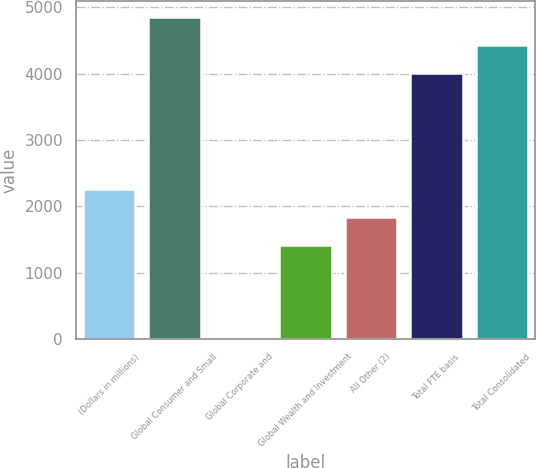Convert chart. <chart><loc_0><loc_0><loc_500><loc_500><bar_chart><fcel>(Dollars in millions)<fcel>Global Consumer and Small<fcel>Global Corporate and<fcel>Global Wealth and Investment<fcel>All Other (2)<fcel>Total FTE basis<fcel>Total Consolidated<nl><fcel>2260<fcel>4852<fcel>14<fcel>1416<fcel>1838<fcel>4008<fcel>4430<nl></chart> 